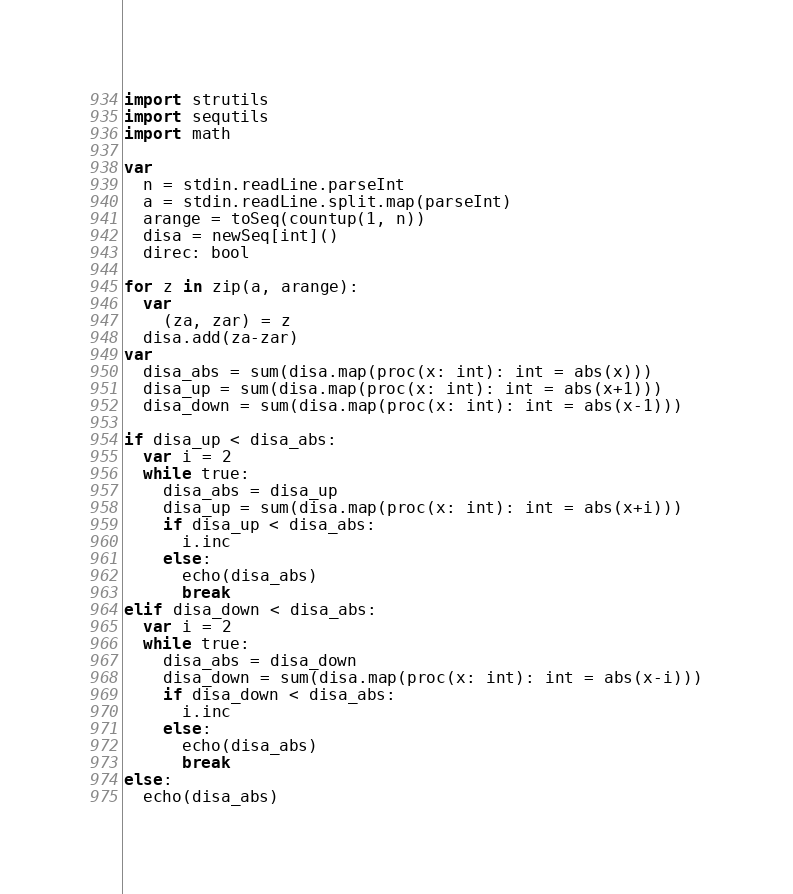<code> <loc_0><loc_0><loc_500><loc_500><_Nim_>import strutils
import sequtils
import math

var
  n = stdin.readLine.parseInt
  a = stdin.readLine.split.map(parseInt)
  arange = toSeq(countup(1, n))
  disa = newSeq[int]()
  direc: bool

for z in zip(a, arange):
  var 
    (za, zar) = z
  disa.add(za-zar)
var
  disa_abs = sum(disa.map(proc(x: int): int = abs(x)))
  disa_up = sum(disa.map(proc(x: int): int = abs(x+1)))
  disa_down = sum(disa.map(proc(x: int): int = abs(x-1)))

if disa_up < disa_abs:
  var i = 2
  while true:
    disa_abs = disa_up
    disa_up = sum(disa.map(proc(x: int): int = abs(x+i)))
    if disa_up < disa_abs:
      i.inc
    else:
      echo(disa_abs)
      break
elif disa_down < disa_abs:
  var i = 2
  while true:
    disa_abs = disa_down
    disa_down = sum(disa.map(proc(x: int): int = abs(x-i)))
    if disa_down < disa_abs:
      i.inc
    else:
      echo(disa_abs)
      break
else:
  echo(disa_abs)
</code> 